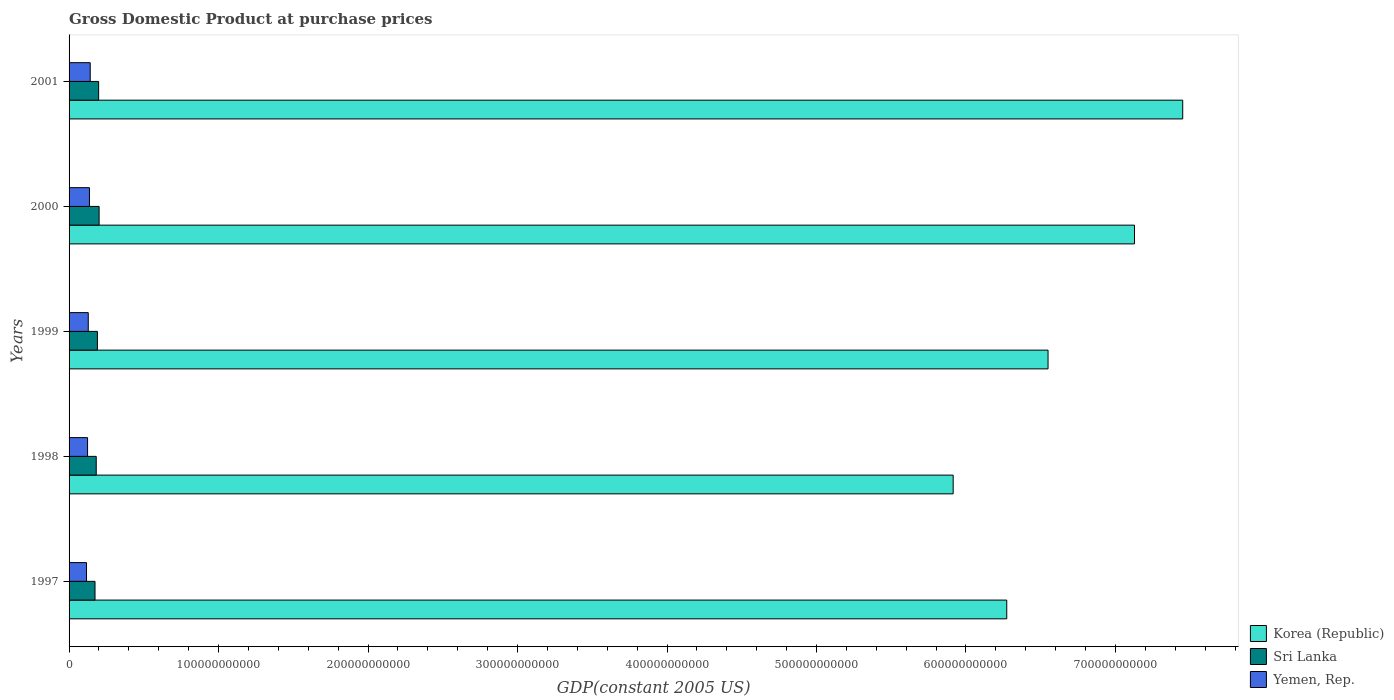How many different coloured bars are there?
Make the answer very short. 3. How many groups of bars are there?
Provide a succinct answer. 5. Are the number of bars per tick equal to the number of legend labels?
Your answer should be very brief. Yes. Are the number of bars on each tick of the Y-axis equal?
Your answer should be very brief. Yes. How many bars are there on the 5th tick from the top?
Ensure brevity in your answer.  3. In how many cases, is the number of bars for a given year not equal to the number of legend labels?
Offer a very short reply. 0. What is the GDP at purchase prices in Sri Lanka in 2001?
Give a very brief answer. 1.98e+1. Across all years, what is the maximum GDP at purchase prices in Sri Lanka?
Offer a terse response. 2.01e+1. Across all years, what is the minimum GDP at purchase prices in Yemen, Rep.?
Provide a succinct answer. 1.17e+1. In which year was the GDP at purchase prices in Korea (Republic) maximum?
Keep it short and to the point. 2001. What is the total GDP at purchase prices in Yemen, Rep. in the graph?
Provide a succinct answer. 6.47e+1. What is the difference between the GDP at purchase prices in Yemen, Rep. in 1998 and that in 1999?
Provide a succinct answer. -4.67e+08. What is the difference between the GDP at purchase prices in Sri Lanka in 1999 and the GDP at purchase prices in Yemen, Rep. in 2001?
Your answer should be compact. 4.80e+09. What is the average GDP at purchase prices in Korea (Republic) per year?
Provide a short and direct response. 6.66e+11. In the year 1999, what is the difference between the GDP at purchase prices in Korea (Republic) and GDP at purchase prices in Yemen, Rep.?
Your response must be concise. 6.42e+11. What is the ratio of the GDP at purchase prices in Korea (Republic) in 1998 to that in 2001?
Make the answer very short. 0.79. Is the GDP at purchase prices in Korea (Republic) in 1997 less than that in 1998?
Provide a succinct answer. No. What is the difference between the highest and the second highest GDP at purchase prices in Korea (Republic)?
Ensure brevity in your answer.  3.23e+1. What is the difference between the highest and the lowest GDP at purchase prices in Yemen, Rep.?
Your answer should be compact. 2.48e+09. In how many years, is the GDP at purchase prices in Korea (Republic) greater than the average GDP at purchase prices in Korea (Republic) taken over all years?
Offer a very short reply. 2. What does the 2nd bar from the top in 1998 represents?
Provide a short and direct response. Sri Lanka. What does the 2nd bar from the bottom in 2001 represents?
Make the answer very short. Sri Lanka. How many bars are there?
Ensure brevity in your answer.  15. Are all the bars in the graph horizontal?
Give a very brief answer. Yes. How many years are there in the graph?
Ensure brevity in your answer.  5. What is the difference between two consecutive major ticks on the X-axis?
Your answer should be very brief. 1.00e+11. Are the values on the major ticks of X-axis written in scientific E-notation?
Ensure brevity in your answer.  No. Does the graph contain any zero values?
Your answer should be very brief. No. How many legend labels are there?
Ensure brevity in your answer.  3. What is the title of the graph?
Ensure brevity in your answer.  Gross Domestic Product at purchase prices. Does "Japan" appear as one of the legend labels in the graph?
Ensure brevity in your answer.  No. What is the label or title of the X-axis?
Ensure brevity in your answer.  GDP(constant 2005 US). What is the label or title of the Y-axis?
Your answer should be very brief. Years. What is the GDP(constant 2005 US) of Korea (Republic) in 1997?
Your answer should be compact. 6.27e+11. What is the GDP(constant 2005 US) of Sri Lanka in 1997?
Give a very brief answer. 1.74e+1. What is the GDP(constant 2005 US) of Yemen, Rep. in 1997?
Ensure brevity in your answer.  1.17e+1. What is the GDP(constant 2005 US) in Korea (Republic) in 1998?
Your answer should be compact. 5.91e+11. What is the GDP(constant 2005 US) of Sri Lanka in 1998?
Give a very brief answer. 1.82e+1. What is the GDP(constant 2005 US) of Yemen, Rep. in 1998?
Your answer should be very brief. 1.24e+1. What is the GDP(constant 2005 US) in Korea (Republic) in 1999?
Your response must be concise. 6.55e+11. What is the GDP(constant 2005 US) of Sri Lanka in 1999?
Your answer should be very brief. 1.90e+1. What is the GDP(constant 2005 US) of Yemen, Rep. in 1999?
Make the answer very short. 1.28e+1. What is the GDP(constant 2005 US) of Korea (Republic) in 2000?
Your answer should be compact. 7.13e+11. What is the GDP(constant 2005 US) in Sri Lanka in 2000?
Ensure brevity in your answer.  2.01e+1. What is the GDP(constant 2005 US) of Yemen, Rep. in 2000?
Offer a terse response. 1.36e+1. What is the GDP(constant 2005 US) in Korea (Republic) in 2001?
Offer a terse response. 7.45e+11. What is the GDP(constant 2005 US) in Sri Lanka in 2001?
Offer a very short reply. 1.98e+1. What is the GDP(constant 2005 US) of Yemen, Rep. in 2001?
Offer a terse response. 1.42e+1. Across all years, what is the maximum GDP(constant 2005 US) of Korea (Republic)?
Provide a succinct answer. 7.45e+11. Across all years, what is the maximum GDP(constant 2005 US) in Sri Lanka?
Provide a succinct answer. 2.01e+1. Across all years, what is the maximum GDP(constant 2005 US) in Yemen, Rep.?
Keep it short and to the point. 1.42e+1. Across all years, what is the minimum GDP(constant 2005 US) of Korea (Republic)?
Keep it short and to the point. 5.91e+11. Across all years, what is the minimum GDP(constant 2005 US) in Sri Lanka?
Provide a short and direct response. 1.74e+1. Across all years, what is the minimum GDP(constant 2005 US) in Yemen, Rep.?
Make the answer very short. 1.17e+1. What is the total GDP(constant 2005 US) in Korea (Republic) in the graph?
Your response must be concise. 3.33e+12. What is the total GDP(constant 2005 US) of Sri Lanka in the graph?
Provide a short and direct response. 9.44e+1. What is the total GDP(constant 2005 US) in Yemen, Rep. in the graph?
Your answer should be very brief. 6.47e+1. What is the difference between the GDP(constant 2005 US) of Korea (Republic) in 1997 and that in 1998?
Keep it short and to the point. 3.58e+1. What is the difference between the GDP(constant 2005 US) in Sri Lanka in 1997 and that in 1998?
Offer a very short reply. -8.15e+08. What is the difference between the GDP(constant 2005 US) in Yemen, Rep. in 1997 and that in 1998?
Your answer should be compact. -7.01e+08. What is the difference between the GDP(constant 2005 US) of Korea (Republic) in 1997 and that in 1999?
Your answer should be compact. -2.76e+1. What is the difference between the GDP(constant 2005 US) of Sri Lanka in 1997 and that in 1999?
Ensure brevity in your answer.  -1.60e+09. What is the difference between the GDP(constant 2005 US) in Yemen, Rep. in 1997 and that in 1999?
Ensure brevity in your answer.  -1.17e+09. What is the difference between the GDP(constant 2005 US) of Korea (Republic) in 1997 and that in 2000?
Offer a terse response. -8.55e+1. What is the difference between the GDP(constant 2005 US) in Sri Lanka in 1997 and that in 2000?
Your answer should be very brief. -2.73e+09. What is the difference between the GDP(constant 2005 US) in Yemen, Rep. in 1997 and that in 2000?
Your response must be concise. -1.96e+09. What is the difference between the GDP(constant 2005 US) of Korea (Republic) in 1997 and that in 2001?
Offer a terse response. -1.18e+11. What is the difference between the GDP(constant 2005 US) of Sri Lanka in 1997 and that in 2001?
Provide a succinct answer. -2.42e+09. What is the difference between the GDP(constant 2005 US) in Yemen, Rep. in 1997 and that in 2001?
Provide a succinct answer. -2.48e+09. What is the difference between the GDP(constant 2005 US) in Korea (Republic) in 1998 and that in 1999?
Ensure brevity in your answer.  -6.35e+1. What is the difference between the GDP(constant 2005 US) of Sri Lanka in 1998 and that in 1999?
Your response must be concise. -7.82e+08. What is the difference between the GDP(constant 2005 US) of Yemen, Rep. in 1998 and that in 1999?
Ensure brevity in your answer.  -4.67e+08. What is the difference between the GDP(constant 2005 US) of Korea (Republic) in 1998 and that in 2000?
Your answer should be very brief. -1.21e+11. What is the difference between the GDP(constant 2005 US) in Sri Lanka in 1998 and that in 2000?
Provide a short and direct response. -1.92e+09. What is the difference between the GDP(constant 2005 US) of Yemen, Rep. in 1998 and that in 2000?
Offer a very short reply. -1.26e+09. What is the difference between the GDP(constant 2005 US) of Korea (Republic) in 1998 and that in 2001?
Give a very brief answer. -1.54e+11. What is the difference between the GDP(constant 2005 US) of Sri Lanka in 1998 and that in 2001?
Keep it short and to the point. -1.61e+09. What is the difference between the GDP(constant 2005 US) of Yemen, Rep. in 1998 and that in 2001?
Provide a short and direct response. -1.78e+09. What is the difference between the GDP(constant 2005 US) of Korea (Republic) in 1999 and that in 2000?
Your response must be concise. -5.78e+1. What is the difference between the GDP(constant 2005 US) of Sri Lanka in 1999 and that in 2000?
Provide a succinct answer. -1.14e+09. What is the difference between the GDP(constant 2005 US) in Yemen, Rep. in 1999 and that in 2000?
Give a very brief answer. -7.94e+08. What is the difference between the GDP(constant 2005 US) in Korea (Republic) in 1999 and that in 2001?
Provide a succinct answer. -9.01e+1. What is the difference between the GDP(constant 2005 US) of Sri Lanka in 1999 and that in 2001?
Your answer should be very brief. -8.27e+08. What is the difference between the GDP(constant 2005 US) in Yemen, Rep. in 1999 and that in 2001?
Provide a short and direct response. -1.31e+09. What is the difference between the GDP(constant 2005 US) in Korea (Republic) in 2000 and that in 2001?
Keep it short and to the point. -3.23e+1. What is the difference between the GDP(constant 2005 US) in Sri Lanka in 2000 and that in 2001?
Provide a succinct answer. 3.10e+08. What is the difference between the GDP(constant 2005 US) of Yemen, Rep. in 2000 and that in 2001?
Offer a very short reply. -5.19e+08. What is the difference between the GDP(constant 2005 US) of Korea (Republic) in 1997 and the GDP(constant 2005 US) of Sri Lanka in 1998?
Offer a very short reply. 6.09e+11. What is the difference between the GDP(constant 2005 US) in Korea (Republic) in 1997 and the GDP(constant 2005 US) in Yemen, Rep. in 1998?
Offer a very short reply. 6.15e+11. What is the difference between the GDP(constant 2005 US) of Sri Lanka in 1997 and the GDP(constant 2005 US) of Yemen, Rep. in 1998?
Keep it short and to the point. 4.98e+09. What is the difference between the GDP(constant 2005 US) of Korea (Republic) in 1997 and the GDP(constant 2005 US) of Sri Lanka in 1999?
Give a very brief answer. 6.08e+11. What is the difference between the GDP(constant 2005 US) in Korea (Republic) in 1997 and the GDP(constant 2005 US) in Yemen, Rep. in 1999?
Provide a succinct answer. 6.14e+11. What is the difference between the GDP(constant 2005 US) in Sri Lanka in 1997 and the GDP(constant 2005 US) in Yemen, Rep. in 1999?
Give a very brief answer. 4.52e+09. What is the difference between the GDP(constant 2005 US) of Korea (Republic) in 1997 and the GDP(constant 2005 US) of Sri Lanka in 2000?
Give a very brief answer. 6.07e+11. What is the difference between the GDP(constant 2005 US) in Korea (Republic) in 1997 and the GDP(constant 2005 US) in Yemen, Rep. in 2000?
Your response must be concise. 6.14e+11. What is the difference between the GDP(constant 2005 US) of Sri Lanka in 1997 and the GDP(constant 2005 US) of Yemen, Rep. in 2000?
Provide a short and direct response. 3.72e+09. What is the difference between the GDP(constant 2005 US) in Korea (Republic) in 1997 and the GDP(constant 2005 US) in Sri Lanka in 2001?
Offer a terse response. 6.08e+11. What is the difference between the GDP(constant 2005 US) of Korea (Republic) in 1997 and the GDP(constant 2005 US) of Yemen, Rep. in 2001?
Your answer should be very brief. 6.13e+11. What is the difference between the GDP(constant 2005 US) in Sri Lanka in 1997 and the GDP(constant 2005 US) in Yemen, Rep. in 2001?
Your answer should be very brief. 3.20e+09. What is the difference between the GDP(constant 2005 US) of Korea (Republic) in 1998 and the GDP(constant 2005 US) of Sri Lanka in 1999?
Your answer should be compact. 5.72e+11. What is the difference between the GDP(constant 2005 US) in Korea (Republic) in 1998 and the GDP(constant 2005 US) in Yemen, Rep. in 1999?
Offer a very short reply. 5.79e+11. What is the difference between the GDP(constant 2005 US) in Sri Lanka in 1998 and the GDP(constant 2005 US) in Yemen, Rep. in 1999?
Provide a short and direct response. 5.33e+09. What is the difference between the GDP(constant 2005 US) of Korea (Republic) in 1998 and the GDP(constant 2005 US) of Sri Lanka in 2000?
Your answer should be very brief. 5.71e+11. What is the difference between the GDP(constant 2005 US) in Korea (Republic) in 1998 and the GDP(constant 2005 US) in Yemen, Rep. in 2000?
Provide a short and direct response. 5.78e+11. What is the difference between the GDP(constant 2005 US) of Sri Lanka in 1998 and the GDP(constant 2005 US) of Yemen, Rep. in 2000?
Offer a terse response. 4.54e+09. What is the difference between the GDP(constant 2005 US) of Korea (Republic) in 1998 and the GDP(constant 2005 US) of Sri Lanka in 2001?
Your response must be concise. 5.72e+11. What is the difference between the GDP(constant 2005 US) of Korea (Republic) in 1998 and the GDP(constant 2005 US) of Yemen, Rep. in 2001?
Make the answer very short. 5.77e+11. What is the difference between the GDP(constant 2005 US) in Sri Lanka in 1998 and the GDP(constant 2005 US) in Yemen, Rep. in 2001?
Offer a very short reply. 4.02e+09. What is the difference between the GDP(constant 2005 US) in Korea (Republic) in 1999 and the GDP(constant 2005 US) in Sri Lanka in 2000?
Give a very brief answer. 6.35e+11. What is the difference between the GDP(constant 2005 US) of Korea (Republic) in 1999 and the GDP(constant 2005 US) of Yemen, Rep. in 2000?
Your answer should be very brief. 6.41e+11. What is the difference between the GDP(constant 2005 US) in Sri Lanka in 1999 and the GDP(constant 2005 US) in Yemen, Rep. in 2000?
Keep it short and to the point. 5.32e+09. What is the difference between the GDP(constant 2005 US) of Korea (Republic) in 1999 and the GDP(constant 2005 US) of Sri Lanka in 2001?
Your answer should be compact. 6.35e+11. What is the difference between the GDP(constant 2005 US) in Korea (Republic) in 1999 and the GDP(constant 2005 US) in Yemen, Rep. in 2001?
Make the answer very short. 6.41e+11. What is the difference between the GDP(constant 2005 US) in Sri Lanka in 1999 and the GDP(constant 2005 US) in Yemen, Rep. in 2001?
Offer a terse response. 4.80e+09. What is the difference between the GDP(constant 2005 US) in Korea (Republic) in 2000 and the GDP(constant 2005 US) in Sri Lanka in 2001?
Make the answer very short. 6.93e+11. What is the difference between the GDP(constant 2005 US) of Korea (Republic) in 2000 and the GDP(constant 2005 US) of Yemen, Rep. in 2001?
Make the answer very short. 6.99e+11. What is the difference between the GDP(constant 2005 US) in Sri Lanka in 2000 and the GDP(constant 2005 US) in Yemen, Rep. in 2001?
Offer a very short reply. 5.94e+09. What is the average GDP(constant 2005 US) of Korea (Republic) per year?
Provide a succinct answer. 6.66e+11. What is the average GDP(constant 2005 US) in Sri Lanka per year?
Make the answer very short. 1.89e+1. What is the average GDP(constant 2005 US) in Yemen, Rep. per year?
Keep it short and to the point. 1.29e+1. In the year 1997, what is the difference between the GDP(constant 2005 US) of Korea (Republic) and GDP(constant 2005 US) of Sri Lanka?
Provide a short and direct response. 6.10e+11. In the year 1997, what is the difference between the GDP(constant 2005 US) in Korea (Republic) and GDP(constant 2005 US) in Yemen, Rep.?
Keep it short and to the point. 6.16e+11. In the year 1997, what is the difference between the GDP(constant 2005 US) in Sri Lanka and GDP(constant 2005 US) in Yemen, Rep.?
Your answer should be very brief. 5.68e+09. In the year 1998, what is the difference between the GDP(constant 2005 US) in Korea (Republic) and GDP(constant 2005 US) in Sri Lanka?
Offer a terse response. 5.73e+11. In the year 1998, what is the difference between the GDP(constant 2005 US) of Korea (Republic) and GDP(constant 2005 US) of Yemen, Rep.?
Give a very brief answer. 5.79e+11. In the year 1998, what is the difference between the GDP(constant 2005 US) in Sri Lanka and GDP(constant 2005 US) in Yemen, Rep.?
Offer a very short reply. 5.80e+09. In the year 1999, what is the difference between the GDP(constant 2005 US) of Korea (Republic) and GDP(constant 2005 US) of Sri Lanka?
Your answer should be compact. 6.36e+11. In the year 1999, what is the difference between the GDP(constant 2005 US) of Korea (Republic) and GDP(constant 2005 US) of Yemen, Rep.?
Ensure brevity in your answer.  6.42e+11. In the year 1999, what is the difference between the GDP(constant 2005 US) of Sri Lanka and GDP(constant 2005 US) of Yemen, Rep.?
Provide a short and direct response. 6.11e+09. In the year 2000, what is the difference between the GDP(constant 2005 US) in Korea (Republic) and GDP(constant 2005 US) in Sri Lanka?
Offer a terse response. 6.93e+11. In the year 2000, what is the difference between the GDP(constant 2005 US) of Korea (Republic) and GDP(constant 2005 US) of Yemen, Rep.?
Give a very brief answer. 6.99e+11. In the year 2000, what is the difference between the GDP(constant 2005 US) in Sri Lanka and GDP(constant 2005 US) in Yemen, Rep.?
Provide a short and direct response. 6.46e+09. In the year 2001, what is the difference between the GDP(constant 2005 US) in Korea (Republic) and GDP(constant 2005 US) in Sri Lanka?
Keep it short and to the point. 7.25e+11. In the year 2001, what is the difference between the GDP(constant 2005 US) of Korea (Republic) and GDP(constant 2005 US) of Yemen, Rep.?
Give a very brief answer. 7.31e+11. In the year 2001, what is the difference between the GDP(constant 2005 US) of Sri Lanka and GDP(constant 2005 US) of Yemen, Rep.?
Provide a short and direct response. 5.63e+09. What is the ratio of the GDP(constant 2005 US) of Korea (Republic) in 1997 to that in 1998?
Make the answer very short. 1.06. What is the ratio of the GDP(constant 2005 US) in Sri Lanka in 1997 to that in 1998?
Make the answer very short. 0.96. What is the ratio of the GDP(constant 2005 US) in Yemen, Rep. in 1997 to that in 1998?
Your answer should be very brief. 0.94. What is the ratio of the GDP(constant 2005 US) of Korea (Republic) in 1997 to that in 1999?
Provide a succinct answer. 0.96. What is the ratio of the GDP(constant 2005 US) of Sri Lanka in 1997 to that in 1999?
Give a very brief answer. 0.92. What is the ratio of the GDP(constant 2005 US) in Yemen, Rep. in 1997 to that in 1999?
Ensure brevity in your answer.  0.91. What is the ratio of the GDP(constant 2005 US) in Korea (Republic) in 1997 to that in 2000?
Provide a short and direct response. 0.88. What is the ratio of the GDP(constant 2005 US) in Sri Lanka in 1997 to that in 2000?
Your answer should be compact. 0.86. What is the ratio of the GDP(constant 2005 US) of Yemen, Rep. in 1997 to that in 2000?
Your answer should be compact. 0.86. What is the ratio of the GDP(constant 2005 US) in Korea (Republic) in 1997 to that in 2001?
Your response must be concise. 0.84. What is the ratio of the GDP(constant 2005 US) of Sri Lanka in 1997 to that in 2001?
Your response must be concise. 0.88. What is the ratio of the GDP(constant 2005 US) of Yemen, Rep. in 1997 to that in 2001?
Provide a short and direct response. 0.82. What is the ratio of the GDP(constant 2005 US) of Korea (Republic) in 1998 to that in 1999?
Keep it short and to the point. 0.9. What is the ratio of the GDP(constant 2005 US) of Sri Lanka in 1998 to that in 1999?
Keep it short and to the point. 0.96. What is the ratio of the GDP(constant 2005 US) of Yemen, Rep. in 1998 to that in 1999?
Ensure brevity in your answer.  0.96. What is the ratio of the GDP(constant 2005 US) of Korea (Republic) in 1998 to that in 2000?
Offer a very short reply. 0.83. What is the ratio of the GDP(constant 2005 US) in Sri Lanka in 1998 to that in 2000?
Provide a succinct answer. 0.9. What is the ratio of the GDP(constant 2005 US) in Yemen, Rep. in 1998 to that in 2000?
Your answer should be compact. 0.91. What is the ratio of the GDP(constant 2005 US) of Korea (Republic) in 1998 to that in 2001?
Provide a short and direct response. 0.79. What is the ratio of the GDP(constant 2005 US) of Sri Lanka in 1998 to that in 2001?
Give a very brief answer. 0.92. What is the ratio of the GDP(constant 2005 US) in Yemen, Rep. in 1998 to that in 2001?
Give a very brief answer. 0.87. What is the ratio of the GDP(constant 2005 US) of Korea (Republic) in 1999 to that in 2000?
Keep it short and to the point. 0.92. What is the ratio of the GDP(constant 2005 US) of Sri Lanka in 1999 to that in 2000?
Your answer should be compact. 0.94. What is the ratio of the GDP(constant 2005 US) of Yemen, Rep. in 1999 to that in 2000?
Provide a short and direct response. 0.94. What is the ratio of the GDP(constant 2005 US) in Korea (Republic) in 1999 to that in 2001?
Make the answer very short. 0.88. What is the ratio of the GDP(constant 2005 US) in Sri Lanka in 1999 to that in 2001?
Offer a very short reply. 0.96. What is the ratio of the GDP(constant 2005 US) in Yemen, Rep. in 1999 to that in 2001?
Make the answer very short. 0.91. What is the ratio of the GDP(constant 2005 US) of Korea (Republic) in 2000 to that in 2001?
Give a very brief answer. 0.96. What is the ratio of the GDP(constant 2005 US) of Sri Lanka in 2000 to that in 2001?
Provide a succinct answer. 1.02. What is the ratio of the GDP(constant 2005 US) in Yemen, Rep. in 2000 to that in 2001?
Your answer should be compact. 0.96. What is the difference between the highest and the second highest GDP(constant 2005 US) of Korea (Republic)?
Keep it short and to the point. 3.23e+1. What is the difference between the highest and the second highest GDP(constant 2005 US) of Sri Lanka?
Offer a terse response. 3.10e+08. What is the difference between the highest and the second highest GDP(constant 2005 US) in Yemen, Rep.?
Offer a terse response. 5.19e+08. What is the difference between the highest and the lowest GDP(constant 2005 US) of Korea (Republic)?
Your response must be concise. 1.54e+11. What is the difference between the highest and the lowest GDP(constant 2005 US) in Sri Lanka?
Your answer should be very brief. 2.73e+09. What is the difference between the highest and the lowest GDP(constant 2005 US) of Yemen, Rep.?
Your answer should be very brief. 2.48e+09. 